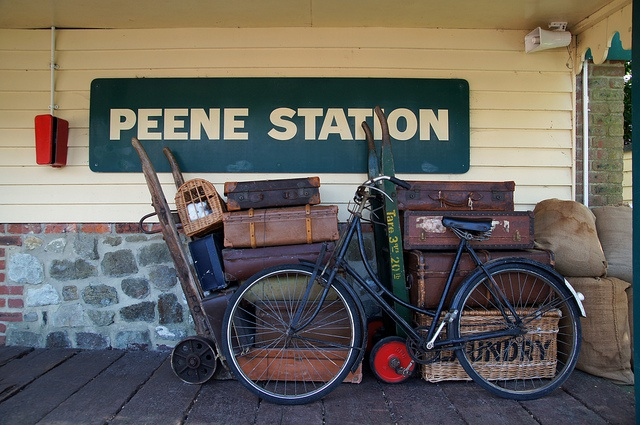Describe the objects in this image and their specific colors. I can see bicycle in olive, black, gray, navy, and blue tones, suitcase in olive, black, gray, and navy tones, suitcase in olive, gray, brown, and maroon tones, suitcase in olive, purple, maroon, and black tones, and suitcase in olive, black, lightgray, and gray tones in this image. 